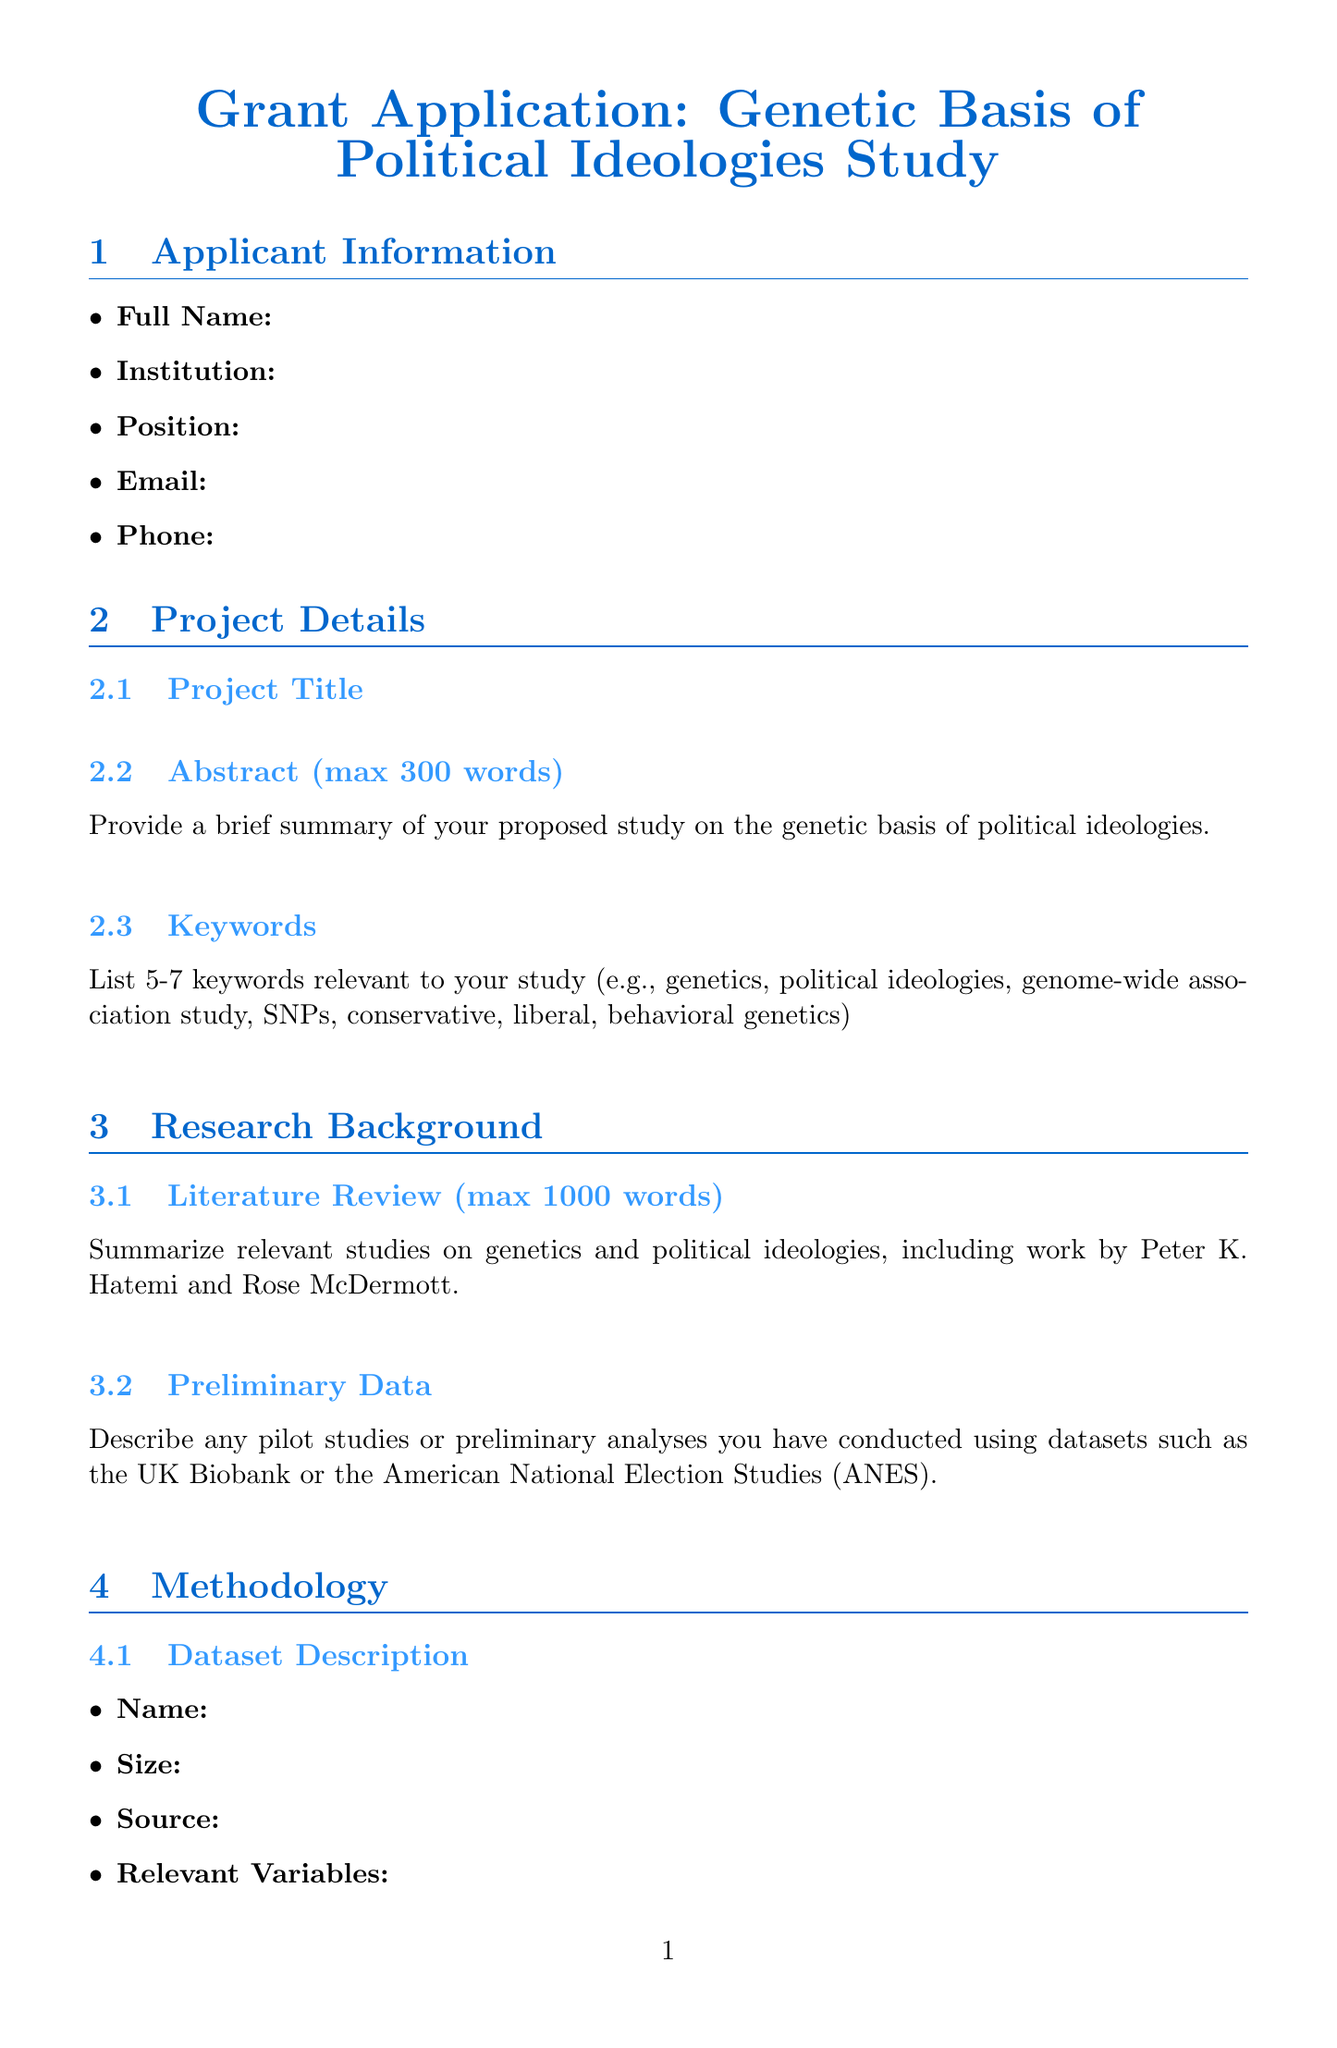what is the maximum word count for the abstract? The maximum word count is explicitly stated in the document as part of the project details.
Answer: 300 who are the key collaborators listed? This question asks for names of collaborators who play significant roles in the project, detailed in the collaborators section.
Answer: Dr. Sarah Johnson, Dr. Michael Chen how many keywords are suggested to be listed? The instruction section specifies the number of keywords that should be included relevant to the study.
Answer: 5-7 what is the funding body for previous grants listed? The funding body is part of the funding history section, detailing where past funding was obtained.
Answer: National Science Foundation 